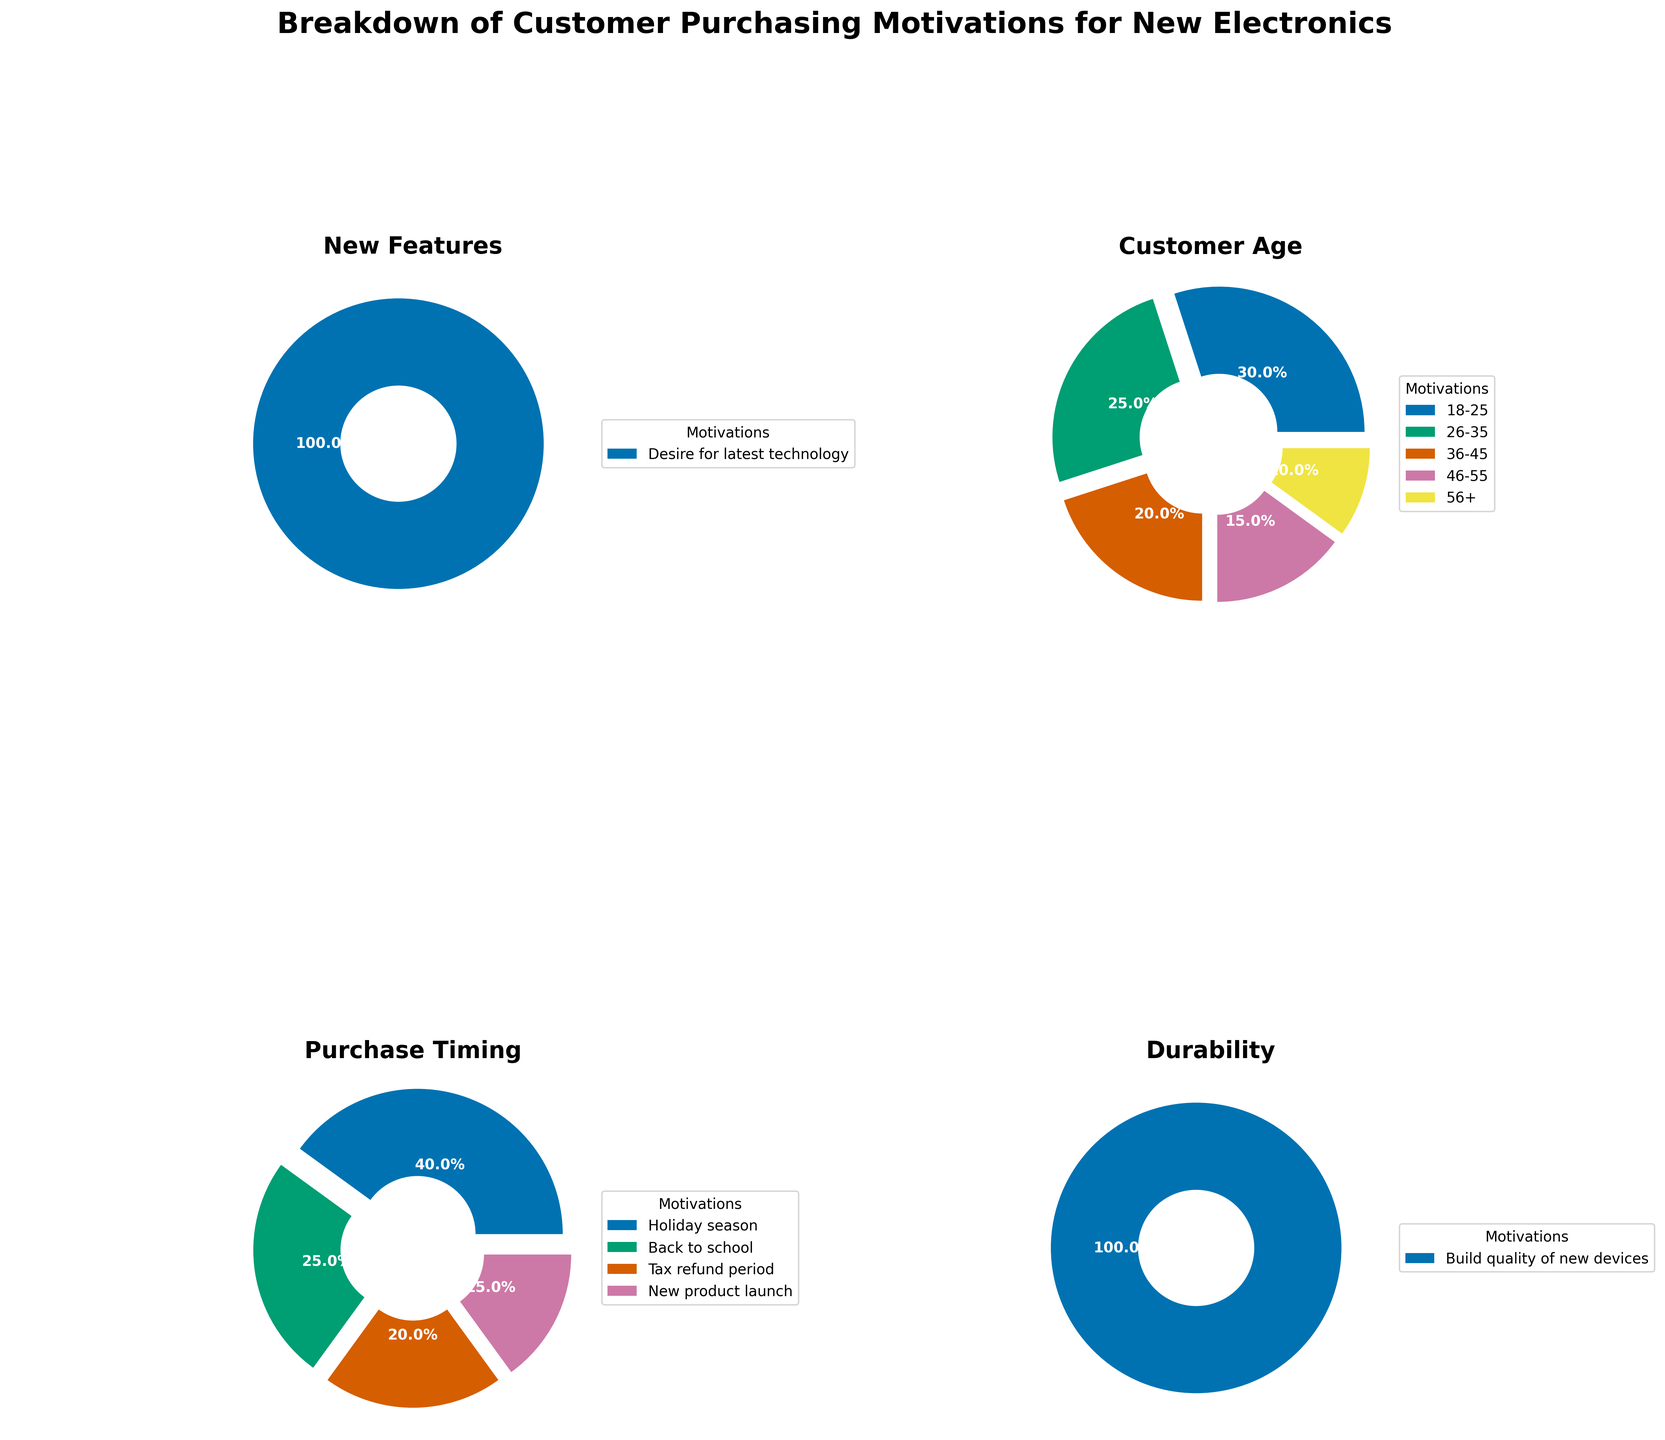What percentage of customers are motivated by a desire for the latest technology? The pie chart segment labeled "Desire for latest technology" represents the portion of customers motivated by new features. According to the figure's legend and segment percent, this motivation is detailed as 35%.
Answer: 35% What is the most common customer age group buying new electronics? Based on the customer age pie chart, the segment with the highest percentage is labeled "18-25," representing 30%. This indicates that the age group 18-25 years old is the most common among customers buying new electronics.
Answer: 18-25 What are the two least common customer age groups buying new electronics, and what are their percentages? The pie chart for customer age shows the smallest segments around the chart. According to the percentages and labels, the groups "46-55" and "56+" show the smallest slices, representing 15% and 10%, respectively.
Answer: 46-55 (15%) and 56+ (10%) Which category has the highest motivation percentage in the "Durability" pie chart? Among the segments in the "Durability" pie chart, the largest segment's percentage is labeled as 30%, indicating that "Build quality of new devices" is the highest motivation.
Answer: Build quality of new devices (30%) How do the percentages of purchases made during the "Holiday season" and "Back to school" period compare? In the "Purchase Timing" pie chart, compare the segments labeled "Holiday season" and "Back to school." "Holiday season" has a percentage of 40%, while "Back to school" has a percentage of 25%. Therefore, "Holiday season" purchases are more common.
Answer: Holiday season (40%) vs. Back to school (25%) What is the combined percentage for the motivations related to product launch and tax refund periods in "Purchase Timing"? To find the combined percentage, add the segments labeled "Tax refund period" (20%) and "New product launch" (15%) from the "Purchase Timing" pie chart: 20% + 15% = 35%.
Answer: 35% What percentage of customers are motivated by planned obsolescence, and how does it compare to those motivated by warranties? From the "New Features" pie chart, the segment for "Planned Obsolescence" represents 25%, and "Warranty" represents 5%. Therefore, customers motivated by planned obsolescence (25%) is higher than those motivated by warranties (5%).
Answer: Planned Obsolescence (25%) > Warranty (5%) What is the smallest motivation percentage in the "New Features" category pie chart and which motivation does it represent? In the "New Features" pie chart, the smallest segment is labeled "Peace of mind with new purchase," which represents the "Warranty" motivation with a percentage of 5%.
Answer: Warranty (5%) Which purchase timing motive has the lowest percentage and what is it? In the "Purchase Timing" pie chart, the segment labeled "New product launch" is the smallest, representing a percentage of 15%.
Answer: New product launch (15%) How many different motivations are represented in each pie chart? Each pie chart visually represents distinct segments with specific motivations. Counting these segments for each chart: "New Features" has 3 motivations, "Customer Age" has 5, "Purchase Timing" has 4, and "Durability" has 1.
Answer: New Features (3), Customer Age (5), Purchase Timing (4), Durability (1) 